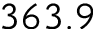<formula> <loc_0><loc_0><loc_500><loc_500>3 6 3 . 9</formula> 